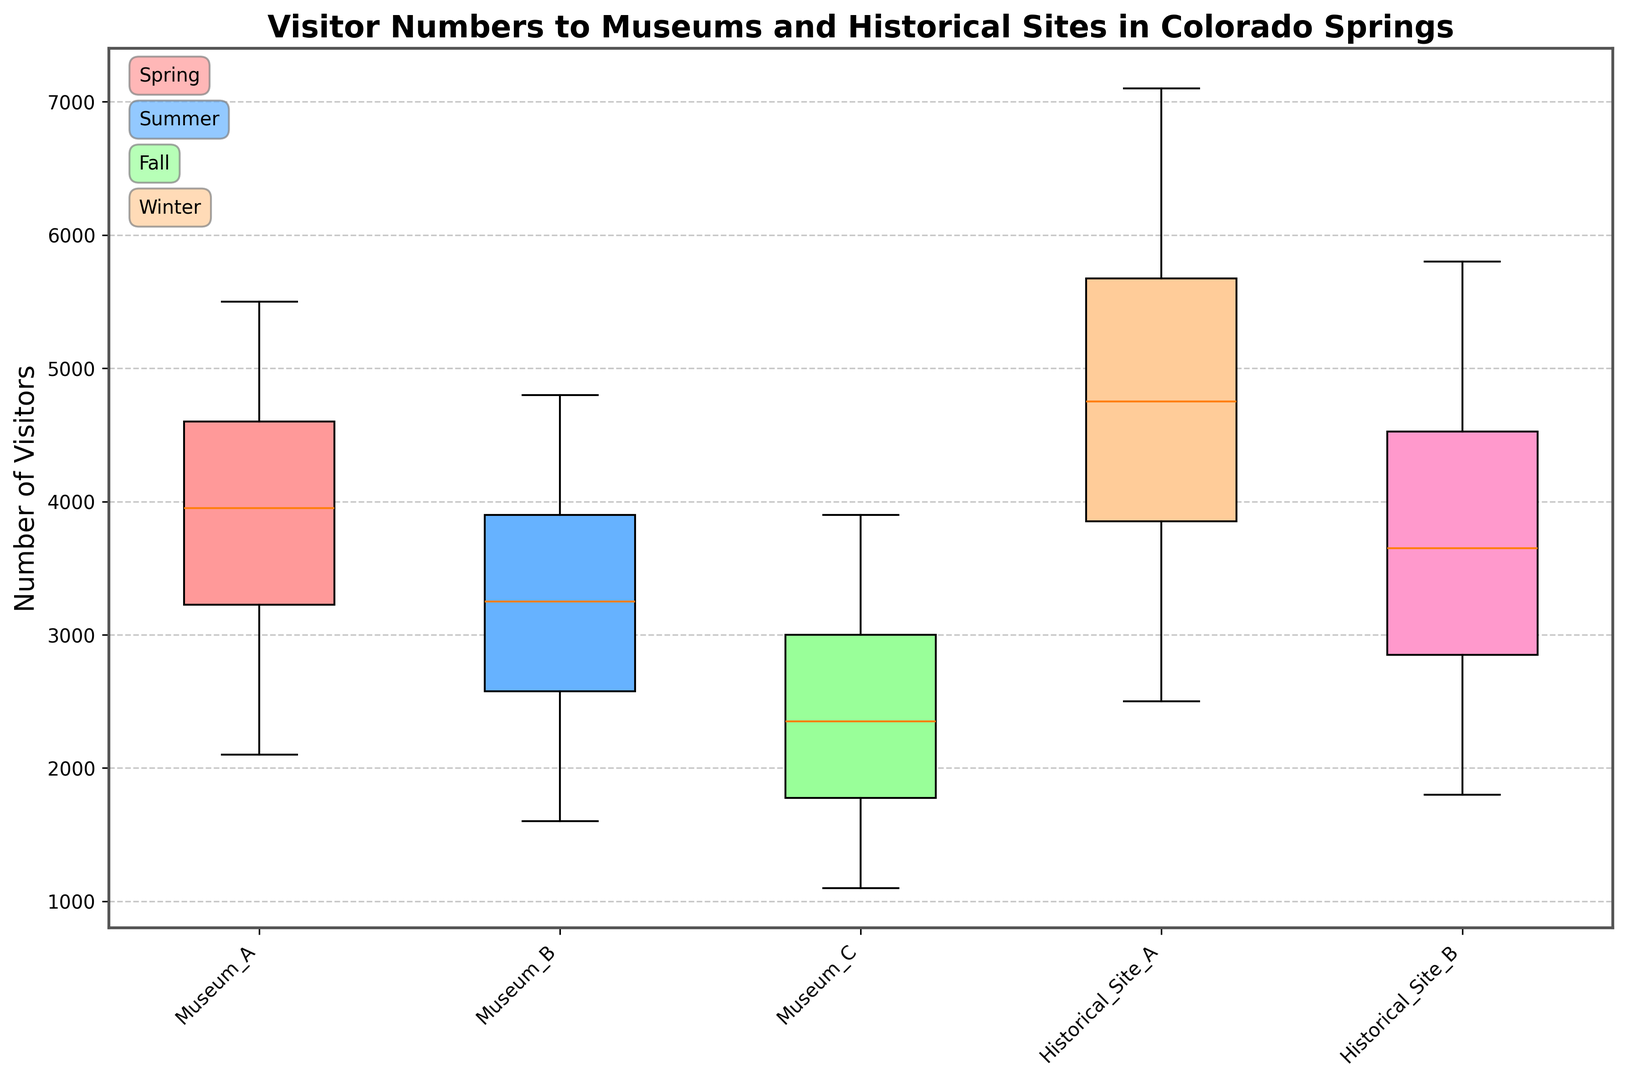Which location has the highest median number of visitors? The middle value in the sorted data set for each location represents the median. From the box plots, Historical Site A has the highest median as its central line is at a higher value compared to others.
Answer: Historical Site A Which season shows the widest range in visitor numbers for all locations? The range is determined by the difference between the maximum and minimum values. The box plots for the Summer season exhibit the widest range in visitor numbers, indicated by the length of the whiskers.
Answer: Summer What is the median number of visitors for Museum B during the Winter season? The box plot's central line within the Museum B section illustrates the median value for the Winter season. It is located around 1750.
Answer: 1750 How does the interquartile range (IQR) of Museum A compare between Spring and Fall? The IQR is the range between the first and third quartiles (the length of the box in the plot). The Spring season for Museum A has a wider box compared to Fall, indicating a larger IQR in Spring.
Answer: Spring has a larger IQR Which museum has the least variability in visitors during the Summer season? The variability within a season can be found by looking at the length of the boxes. Museum C has the shortest box during the Summer season, indicating the least variability.
Answer: Museum C During which season does Historical Site B have the most visitors, considering quartiles? The upper quartile represents the highest 25% of data. Historical Site B shows the highest visitors in the Summer season, where the upper quartile is significantly higher than in other seasons.
Answer: Summer In which season is the difference between the maximum visitors for Historical Site A and Museum C the greatest? To find the difference, observe the extent of the whiskers (maximum values). In Summer, Historical Site A reaches a very high value, while Museum C has relatively lower values, making the difference greatest.
Answer: Summer How does the median number of visitors for Historical Site A compare between Fall and Winter? The central line in the box representing the median for Fall is noticeably higher than the median line for Winter in Historical Site A.
Answer: Fall has a higher median Which location shows the smallest median number of visitors during the Winter? The central line in the box for the Winter season shows Museum C with the lowest median number of visitors, as compared to other locations.
Answer: Museum C What pattern can be observed about the visitor numbers in different seasons? The visitor numbers for all locations tend to be highest in Summer and lowest in Winter, with moderate values in Spring and Fall. This is reflected by the relative positions and ranges of the box plots across seasons.
Answer: Highest in Summer, lowest in Winter, moderate in Spring and Fall 